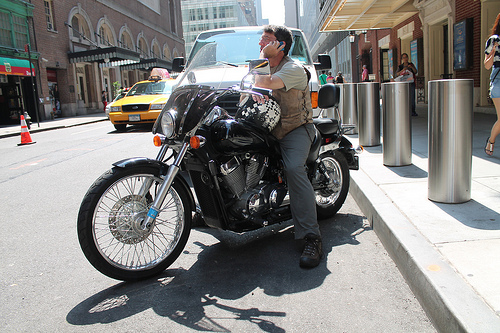Which place is it? The photo depicts an urban street scene that appears to be in a busy city, judging by the yellow taxi and architectural styles. 